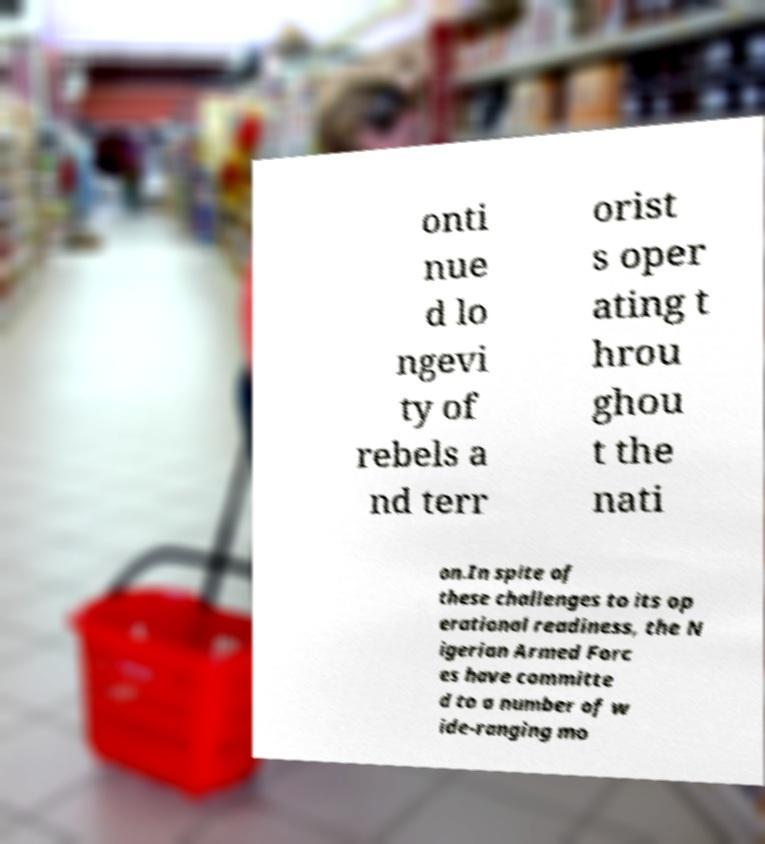I need the written content from this picture converted into text. Can you do that? onti nue d lo ngevi ty of rebels a nd terr orist s oper ating t hrou ghou t the nati on.In spite of these challenges to its op erational readiness, the N igerian Armed Forc es have committe d to a number of w ide-ranging mo 